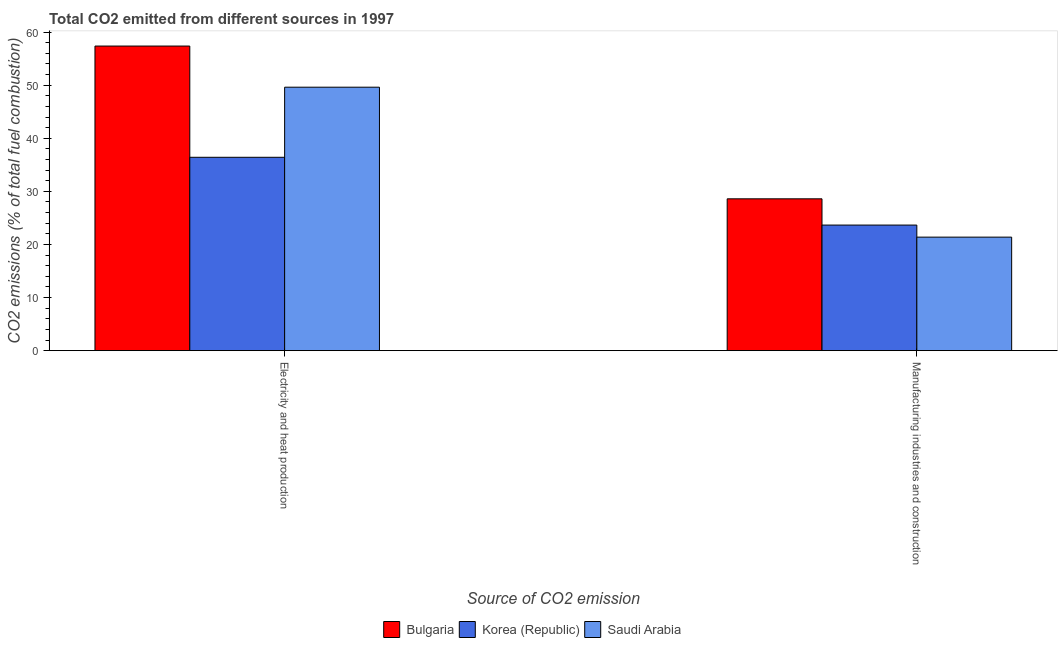Are the number of bars on each tick of the X-axis equal?
Ensure brevity in your answer.  Yes. How many bars are there on the 2nd tick from the left?
Ensure brevity in your answer.  3. How many bars are there on the 2nd tick from the right?
Keep it short and to the point. 3. What is the label of the 2nd group of bars from the left?
Your answer should be compact. Manufacturing industries and construction. What is the co2 emissions due to manufacturing industries in Korea (Republic)?
Keep it short and to the point. 23.65. Across all countries, what is the maximum co2 emissions due to manufacturing industries?
Provide a short and direct response. 28.6. Across all countries, what is the minimum co2 emissions due to manufacturing industries?
Keep it short and to the point. 21.38. In which country was the co2 emissions due to manufacturing industries minimum?
Keep it short and to the point. Saudi Arabia. What is the total co2 emissions due to manufacturing industries in the graph?
Make the answer very short. 73.63. What is the difference between the co2 emissions due to manufacturing industries in Saudi Arabia and that in Korea (Republic)?
Give a very brief answer. -2.27. What is the difference between the co2 emissions due to manufacturing industries in Bulgaria and the co2 emissions due to electricity and heat production in Korea (Republic)?
Offer a terse response. -7.82. What is the average co2 emissions due to electricity and heat production per country?
Make the answer very short. 47.8. What is the difference between the co2 emissions due to electricity and heat production and co2 emissions due to manufacturing industries in Bulgaria?
Offer a terse response. 28.77. In how many countries, is the co2 emissions due to electricity and heat production greater than 4 %?
Provide a succinct answer. 3. What is the ratio of the co2 emissions due to manufacturing industries in Bulgaria to that in Saudi Arabia?
Offer a very short reply. 1.34. In how many countries, is the co2 emissions due to electricity and heat production greater than the average co2 emissions due to electricity and heat production taken over all countries?
Make the answer very short. 2. What does the 1st bar from the right in Electricity and heat production represents?
Your answer should be compact. Saudi Arabia. Are all the bars in the graph horizontal?
Ensure brevity in your answer.  No. What is the difference between two consecutive major ticks on the Y-axis?
Ensure brevity in your answer.  10. Where does the legend appear in the graph?
Your answer should be compact. Bottom center. How many legend labels are there?
Provide a short and direct response. 3. How are the legend labels stacked?
Provide a succinct answer. Horizontal. What is the title of the graph?
Make the answer very short. Total CO2 emitted from different sources in 1997. Does "Denmark" appear as one of the legend labels in the graph?
Offer a terse response. No. What is the label or title of the X-axis?
Your answer should be very brief. Source of CO2 emission. What is the label or title of the Y-axis?
Your response must be concise. CO2 emissions (% of total fuel combustion). What is the CO2 emissions (% of total fuel combustion) in Bulgaria in Electricity and heat production?
Your response must be concise. 57.37. What is the CO2 emissions (% of total fuel combustion) in Korea (Republic) in Electricity and heat production?
Offer a terse response. 36.42. What is the CO2 emissions (% of total fuel combustion) in Saudi Arabia in Electricity and heat production?
Your answer should be compact. 49.62. What is the CO2 emissions (% of total fuel combustion) of Bulgaria in Manufacturing industries and construction?
Give a very brief answer. 28.6. What is the CO2 emissions (% of total fuel combustion) of Korea (Republic) in Manufacturing industries and construction?
Offer a very short reply. 23.65. What is the CO2 emissions (% of total fuel combustion) in Saudi Arabia in Manufacturing industries and construction?
Ensure brevity in your answer.  21.38. Across all Source of CO2 emission, what is the maximum CO2 emissions (% of total fuel combustion) of Bulgaria?
Offer a very short reply. 57.37. Across all Source of CO2 emission, what is the maximum CO2 emissions (% of total fuel combustion) in Korea (Republic)?
Offer a terse response. 36.42. Across all Source of CO2 emission, what is the maximum CO2 emissions (% of total fuel combustion) in Saudi Arabia?
Provide a short and direct response. 49.62. Across all Source of CO2 emission, what is the minimum CO2 emissions (% of total fuel combustion) of Bulgaria?
Offer a terse response. 28.6. Across all Source of CO2 emission, what is the minimum CO2 emissions (% of total fuel combustion) of Korea (Republic)?
Provide a short and direct response. 23.65. Across all Source of CO2 emission, what is the minimum CO2 emissions (% of total fuel combustion) in Saudi Arabia?
Offer a terse response. 21.38. What is the total CO2 emissions (% of total fuel combustion) of Bulgaria in the graph?
Keep it short and to the point. 85.97. What is the total CO2 emissions (% of total fuel combustion) in Korea (Republic) in the graph?
Offer a very short reply. 60.07. What is the total CO2 emissions (% of total fuel combustion) of Saudi Arabia in the graph?
Your response must be concise. 71. What is the difference between the CO2 emissions (% of total fuel combustion) in Bulgaria in Electricity and heat production and that in Manufacturing industries and construction?
Your response must be concise. 28.77. What is the difference between the CO2 emissions (% of total fuel combustion) of Korea (Republic) in Electricity and heat production and that in Manufacturing industries and construction?
Your answer should be very brief. 12.77. What is the difference between the CO2 emissions (% of total fuel combustion) of Saudi Arabia in Electricity and heat production and that in Manufacturing industries and construction?
Make the answer very short. 28.24. What is the difference between the CO2 emissions (% of total fuel combustion) of Bulgaria in Electricity and heat production and the CO2 emissions (% of total fuel combustion) of Korea (Republic) in Manufacturing industries and construction?
Your answer should be compact. 33.72. What is the difference between the CO2 emissions (% of total fuel combustion) in Bulgaria in Electricity and heat production and the CO2 emissions (% of total fuel combustion) in Saudi Arabia in Manufacturing industries and construction?
Offer a terse response. 35.99. What is the difference between the CO2 emissions (% of total fuel combustion) in Korea (Republic) in Electricity and heat production and the CO2 emissions (% of total fuel combustion) in Saudi Arabia in Manufacturing industries and construction?
Make the answer very short. 15.04. What is the average CO2 emissions (% of total fuel combustion) in Bulgaria per Source of CO2 emission?
Ensure brevity in your answer.  42.98. What is the average CO2 emissions (% of total fuel combustion) in Korea (Republic) per Source of CO2 emission?
Make the answer very short. 30.04. What is the average CO2 emissions (% of total fuel combustion) of Saudi Arabia per Source of CO2 emission?
Offer a terse response. 35.5. What is the difference between the CO2 emissions (% of total fuel combustion) of Bulgaria and CO2 emissions (% of total fuel combustion) of Korea (Republic) in Electricity and heat production?
Provide a succinct answer. 20.95. What is the difference between the CO2 emissions (% of total fuel combustion) in Bulgaria and CO2 emissions (% of total fuel combustion) in Saudi Arabia in Electricity and heat production?
Your answer should be very brief. 7.75. What is the difference between the CO2 emissions (% of total fuel combustion) in Korea (Republic) and CO2 emissions (% of total fuel combustion) in Saudi Arabia in Electricity and heat production?
Your answer should be very brief. -13.2. What is the difference between the CO2 emissions (% of total fuel combustion) of Bulgaria and CO2 emissions (% of total fuel combustion) of Korea (Republic) in Manufacturing industries and construction?
Make the answer very short. 4.94. What is the difference between the CO2 emissions (% of total fuel combustion) in Bulgaria and CO2 emissions (% of total fuel combustion) in Saudi Arabia in Manufacturing industries and construction?
Provide a succinct answer. 7.22. What is the difference between the CO2 emissions (% of total fuel combustion) of Korea (Republic) and CO2 emissions (% of total fuel combustion) of Saudi Arabia in Manufacturing industries and construction?
Your response must be concise. 2.27. What is the ratio of the CO2 emissions (% of total fuel combustion) of Bulgaria in Electricity and heat production to that in Manufacturing industries and construction?
Provide a succinct answer. 2.01. What is the ratio of the CO2 emissions (% of total fuel combustion) in Korea (Republic) in Electricity and heat production to that in Manufacturing industries and construction?
Your answer should be very brief. 1.54. What is the ratio of the CO2 emissions (% of total fuel combustion) in Saudi Arabia in Electricity and heat production to that in Manufacturing industries and construction?
Provide a succinct answer. 2.32. What is the difference between the highest and the second highest CO2 emissions (% of total fuel combustion) of Bulgaria?
Ensure brevity in your answer.  28.77. What is the difference between the highest and the second highest CO2 emissions (% of total fuel combustion) in Korea (Republic)?
Provide a short and direct response. 12.77. What is the difference between the highest and the second highest CO2 emissions (% of total fuel combustion) in Saudi Arabia?
Offer a terse response. 28.24. What is the difference between the highest and the lowest CO2 emissions (% of total fuel combustion) in Bulgaria?
Give a very brief answer. 28.77. What is the difference between the highest and the lowest CO2 emissions (% of total fuel combustion) in Korea (Republic)?
Your response must be concise. 12.77. What is the difference between the highest and the lowest CO2 emissions (% of total fuel combustion) in Saudi Arabia?
Make the answer very short. 28.24. 